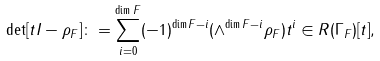Convert formula to latex. <formula><loc_0><loc_0><loc_500><loc_500>\det [ t I - \rho _ { F } ] \colon = \sum _ { i = 0 } ^ { \dim F } ( - 1 ) ^ { \dim F - i } ( \wedge ^ { \dim F - i } \rho _ { F } ) t ^ { i } \in R ( \Gamma _ { F } ) [ t ] ,</formula> 